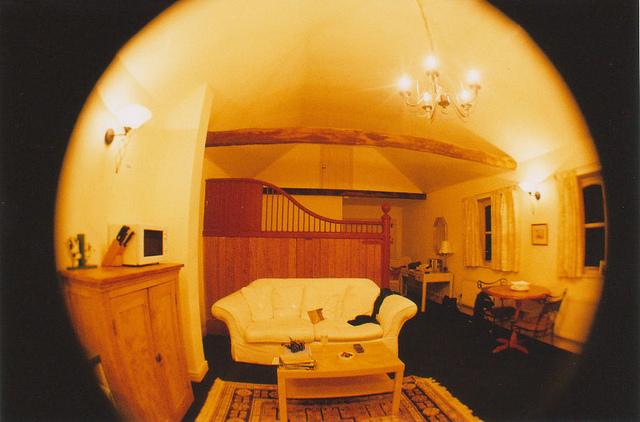How many windows are visible?
Answer briefly. 2. What is the top of the coffee table made of?
Give a very brief answer. Wood. How many tables are in this room?
Give a very brief answer. 3. What is the blue thing on the wall?
Answer briefly. Picture. What color is the couch?
Write a very short answer. White. 